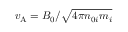<formula> <loc_0><loc_0><loc_500><loc_500>v _ { A } = B _ { 0 } / \sqrt { 4 \pi n _ { 0 i } m _ { i } }</formula> 